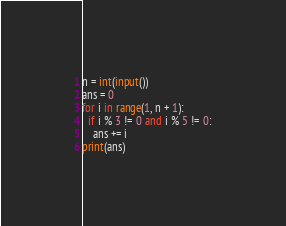Convert code to text. <code><loc_0><loc_0><loc_500><loc_500><_Python_>n = int(input())
ans = 0
for i in range(1, n + 1):
  if i % 3 != 0 and i % 5 != 0:
    ans += i
print(ans)</code> 